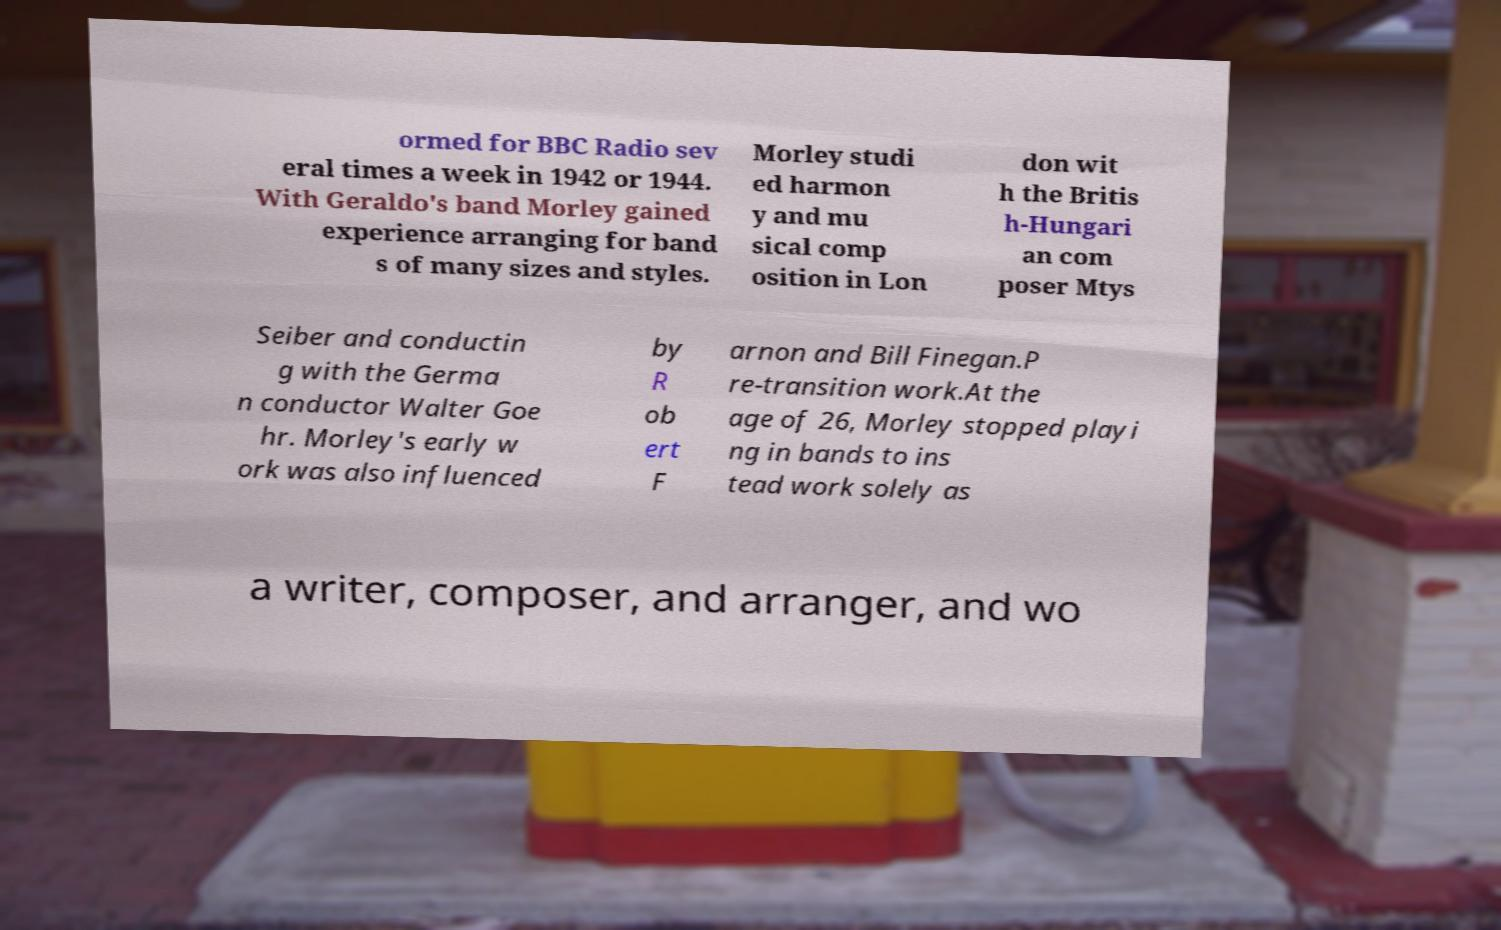Could you assist in decoding the text presented in this image and type it out clearly? ormed for BBC Radio sev eral times a week in 1942 or 1944. With Geraldo's band Morley gained experience arranging for band s of many sizes and styles. Morley studi ed harmon y and mu sical comp osition in Lon don wit h the Britis h-Hungari an com poser Mtys Seiber and conductin g with the Germa n conductor Walter Goe hr. Morley's early w ork was also influenced by R ob ert F arnon and Bill Finegan.P re-transition work.At the age of 26, Morley stopped playi ng in bands to ins tead work solely as a writer, composer, and arranger, and wo 